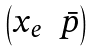<formula> <loc_0><loc_0><loc_500><loc_500>\begin{pmatrix} x _ { e } & \bar { p } \\ \end{pmatrix}</formula> 